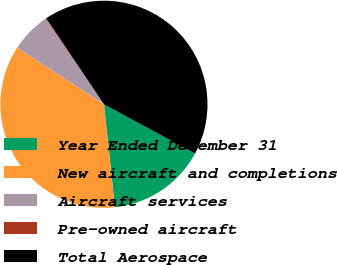<chart> <loc_0><loc_0><loc_500><loc_500><pie_chart><fcel>Year Ended December 31<fcel>New aircraft and completions<fcel>Aircraft services<fcel>Pre-owned aircraft<fcel>Total Aerospace<nl><fcel>15.41%<fcel>35.9%<fcel>6.26%<fcel>0.14%<fcel>42.3%<nl></chart> 